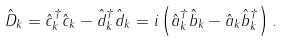<formula> <loc_0><loc_0><loc_500><loc_500>\hat { D } _ { k } = \hat { c } _ { k } ^ { \dag } \hat { c } _ { k } - \hat { d } _ { k } ^ { \dag } \hat { d } _ { k } = i \left ( \hat { a } _ { k } ^ { \dag } \hat { b } _ { k } - \hat { a } _ { k } \hat { b } _ { k } ^ { \dag } \right ) .</formula> 